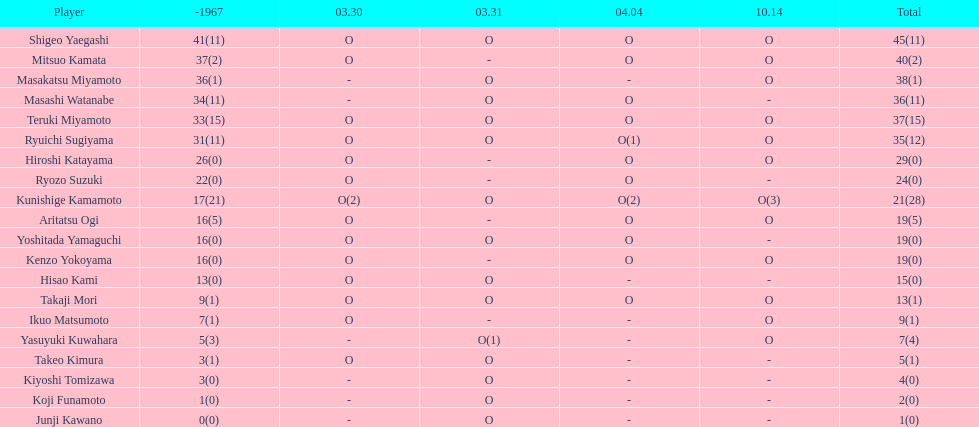What is the cumulative number of mitsuo kamata's belongings? 40(2). 